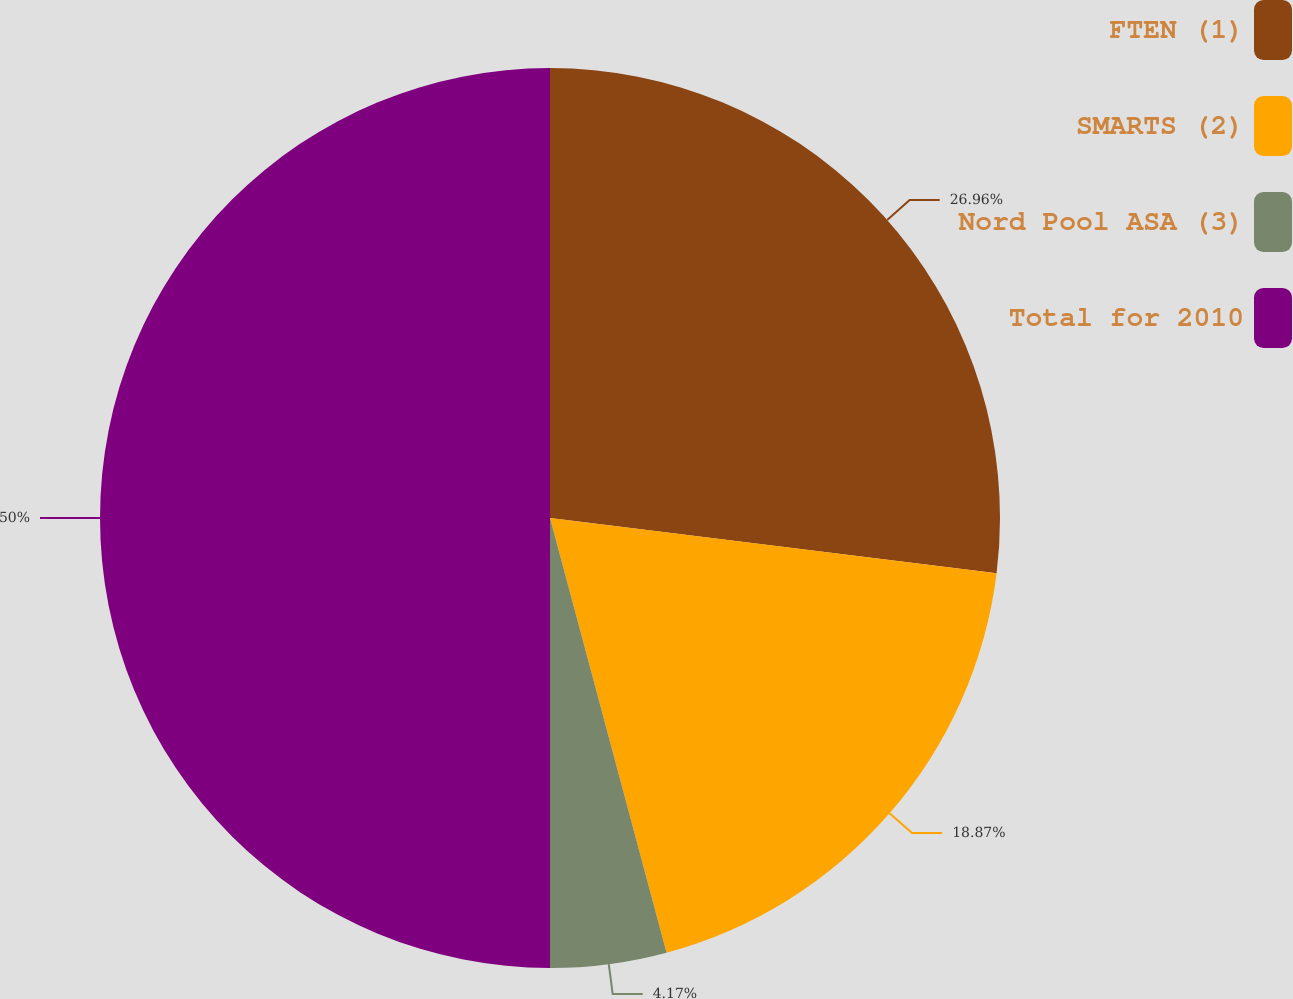Convert chart. <chart><loc_0><loc_0><loc_500><loc_500><pie_chart><fcel>FTEN (1)<fcel>SMARTS (2)<fcel>Nord Pool ASA (3)<fcel>Total for 2010<nl><fcel>26.96%<fcel>18.87%<fcel>4.17%<fcel>50.0%<nl></chart> 